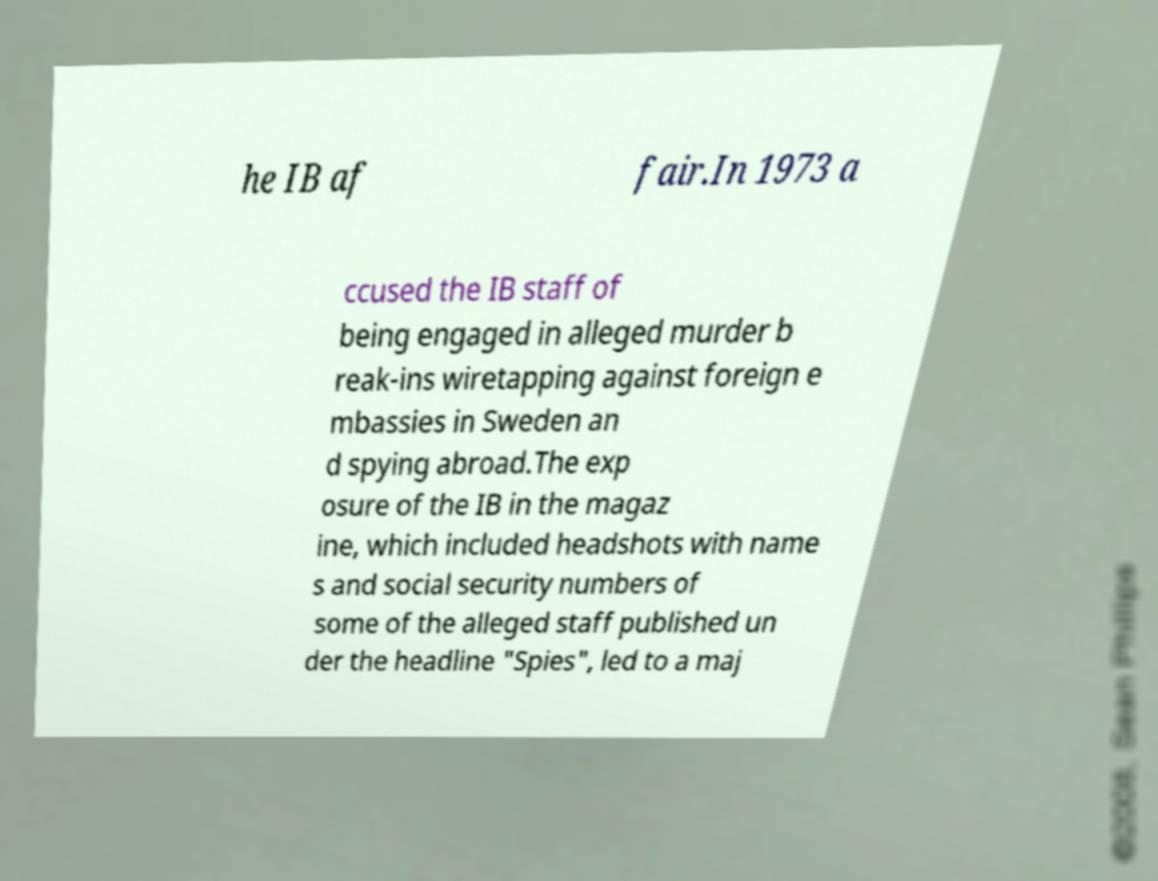For documentation purposes, I need the text within this image transcribed. Could you provide that? he IB af fair.In 1973 a ccused the IB staff of being engaged in alleged murder b reak-ins wiretapping against foreign e mbassies in Sweden an d spying abroad.The exp osure of the IB in the magaz ine, which included headshots with name s and social security numbers of some of the alleged staff published un der the headline "Spies", led to a maj 